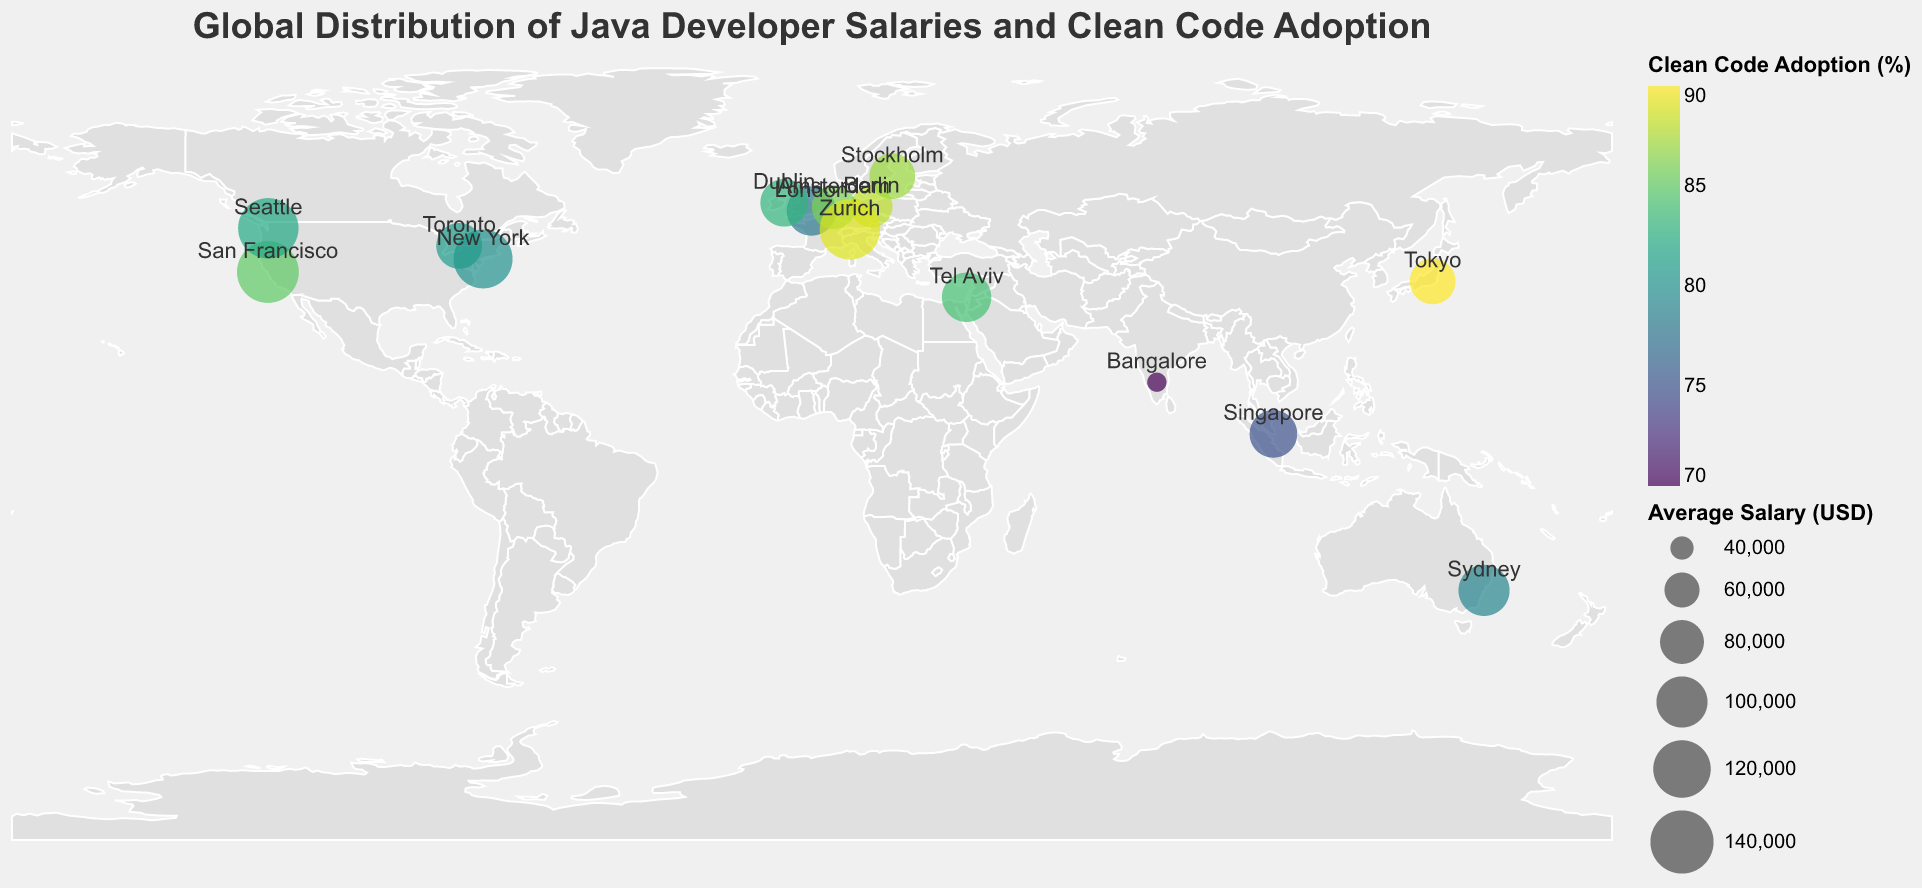What is the average salary in San Francisco? The average salary in San Francisco is displayed as one of the data points in the figure. According to the provided data, it is directly shown as 135,000 USD.
Answer: 135,000 USD Which city in Europe has the highest average Java developer salary? European cities in the plot include London, Berlin, Amsterdam, Zurich, Stockholm, and Dublin. Among these, the average salaries are 95,000 USD (London), 75,000 USD (Berlin), 80,000 USD (Amsterdam), 130,000 USD (Zurich), 85,000 USD (Stockholm), and 90,000 USD (Dublin). Zurich has the highest average salary among them.
Answer: Zurich Compare the clean code adoption rates between San Francisco and Bangalore. Which one is higher and by how much? San Francisco's clean code adoption rate is 85%, while Bangalore's is 70%. The difference is 85% - 70% = 15%. San Francisco has a higher clean code adoption rate by 15 percentage points.
Answer: San Francisco by 15% What is the relationship between average salary and clean code adoption for Zurich? The plot uses color to represent clean code adoption and size of the circle to represent average salary. For Zurich, the average salary is 130,000 USD, and the clean code adoption rate is 89%.
Answer: 130,000 USD, 89% Which city has the lowest average Java developer salary, and what is its clean code adoption rate? The city with the lowest average salary is Bangalore, with an average salary of 35,000 USD. The clean code adoption rate in Bangalore is 70%.
Answer: Bangalore, 70% Which city in Asia has the highest clean code adoption rate? Asian cities in the plot include Bangalore, Singapore, and Tokyo. Their clean code adoption rates are 70% (Bangalore), 75% (Singapore), and 90% (Tokyo). Tokyo has the highest clean code adoption rate in Asia.
Answer: Tokyo Find the sum of the average salaries for New York, Seattle, and Toronto. New York has an average salary of 125,000 USD, Seattle has 130,000 USD, and Toronto has 85,000 USD. The total sum is 125,000 + 130,000 + 85,000 = 340,000 USD.
Answer: 340,000 USD Is there any city outside the USA with a higher average salary than Seattle? Seattle's average salary is 130,000 USD. Among non-USA cities, the highest average salary is in Zurich (130,000 USD), which is equal but not higher. Therefore, no city outside the USA has a higher salary than Seattle in the given data.
Answer: No What is the difference in clean code adoption rates between the cities with the highest and lowest salaries? The city with the highest salary is San Francisco (135,000 USD) with a clean code adoption rate of 85%. The city with the lowest salary is Bangalore (35,000 USD) with a clean code adoption rate of 70%. The difference is 85% - 70% = 15%.
Answer: 15% How many cities have an average salary below 100,000 USD? The cities with salaries below 100,000 USD are London (95,000 USD), Berlin (75,000 USD), Amsterdam (80,000 USD), Bangalore (35,000 USD), Singapore (90,000 USD), Tokyo (85,000 USD), Tel Aviv (95,000 USD), Toronto (85,000 USD), Stockholm (85,000 USD), and Dublin (90,000 USD). There are 10 such cities.
Answer: 10 